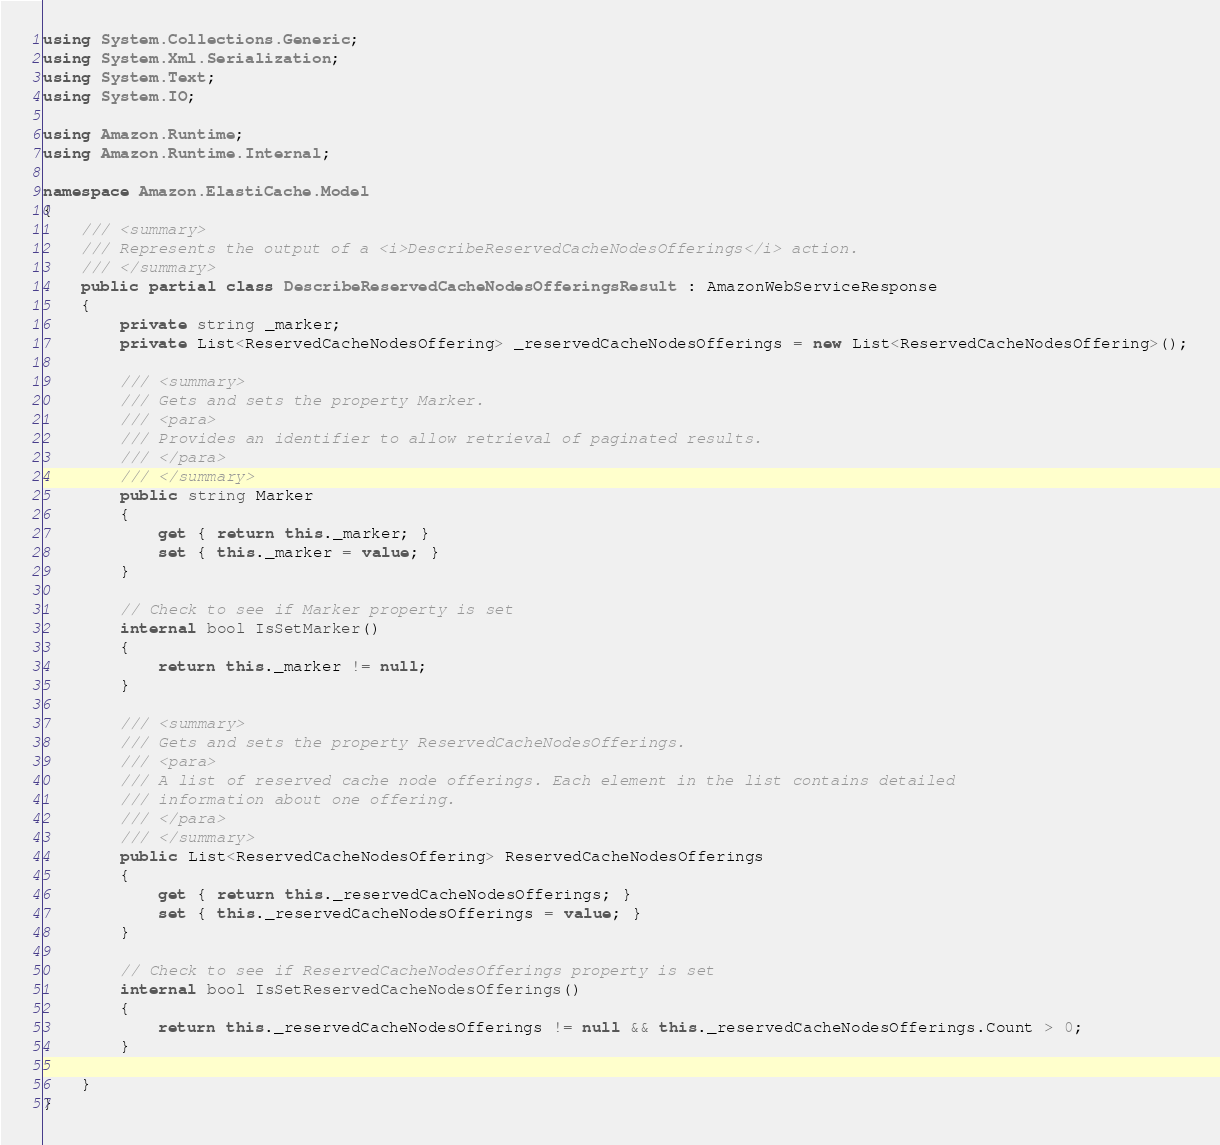<code> <loc_0><loc_0><loc_500><loc_500><_C#_>using System.Collections.Generic;
using System.Xml.Serialization;
using System.Text;
using System.IO;

using Amazon.Runtime;
using Amazon.Runtime.Internal;

namespace Amazon.ElastiCache.Model
{
    /// <summary>
    /// Represents the output of a <i>DescribeReservedCacheNodesOfferings</i> action.
    /// </summary>
    public partial class DescribeReservedCacheNodesOfferingsResult : AmazonWebServiceResponse
    {
        private string _marker;
        private List<ReservedCacheNodesOffering> _reservedCacheNodesOfferings = new List<ReservedCacheNodesOffering>();

        /// <summary>
        /// Gets and sets the property Marker. 
        /// <para>
        /// Provides an identifier to allow retrieval of paginated results.
        /// </para>
        /// </summary>
        public string Marker
        {
            get { return this._marker; }
            set { this._marker = value; }
        }

        // Check to see if Marker property is set
        internal bool IsSetMarker()
        {
            return this._marker != null;
        }

        /// <summary>
        /// Gets and sets the property ReservedCacheNodesOfferings. 
        /// <para>
        /// A list of reserved cache node offerings. Each element in the list contains detailed
        /// information about one offering.
        /// </para>
        /// </summary>
        public List<ReservedCacheNodesOffering> ReservedCacheNodesOfferings
        {
            get { return this._reservedCacheNodesOfferings; }
            set { this._reservedCacheNodesOfferings = value; }
        }

        // Check to see if ReservedCacheNodesOfferings property is set
        internal bool IsSetReservedCacheNodesOfferings()
        {
            return this._reservedCacheNodesOfferings != null && this._reservedCacheNodesOfferings.Count > 0; 
        }

    }
}</code> 